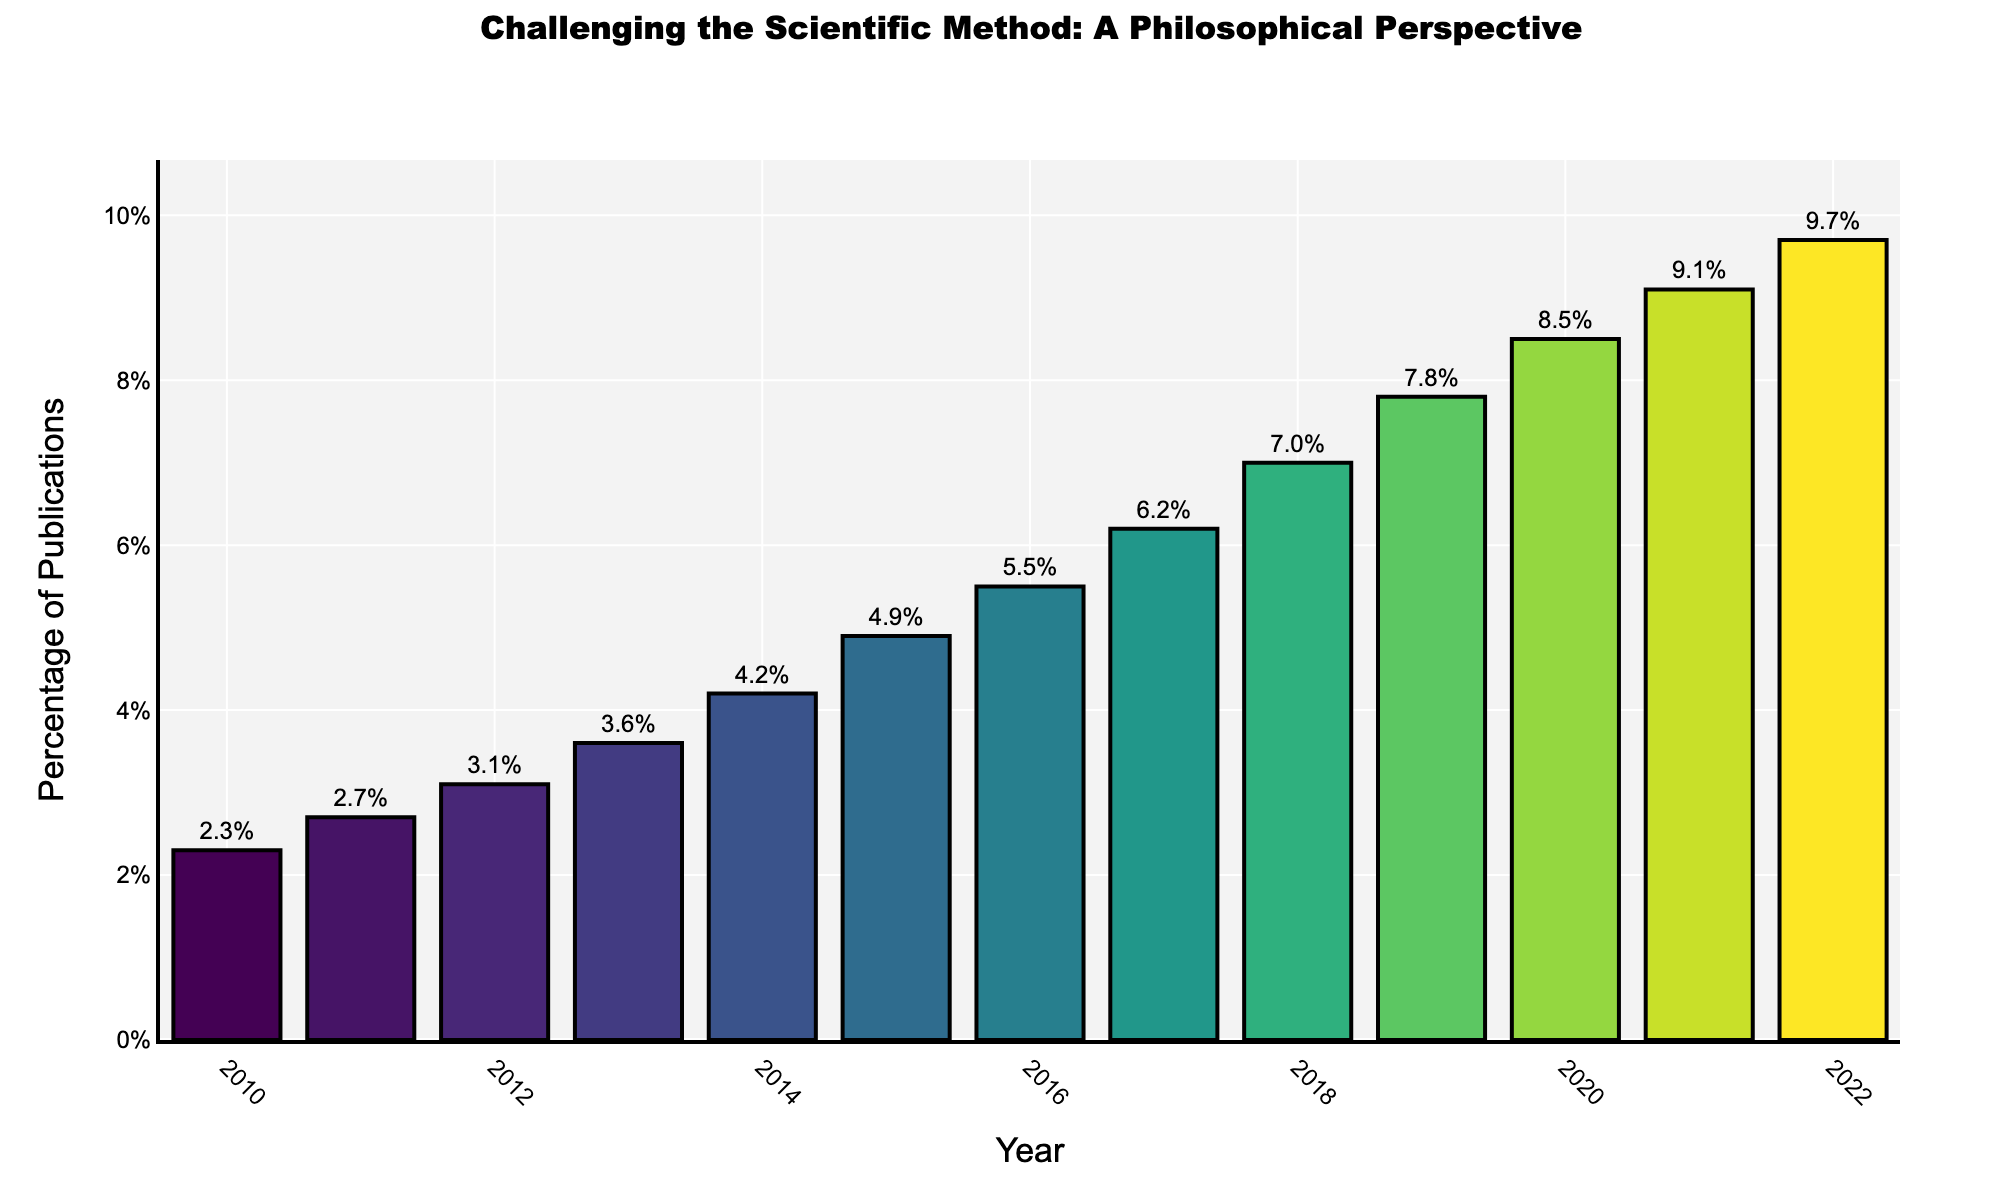What year has the highest percentage of publications challenging the scientific method? By visually observing the bar heights, the highest bar represents 2022. Hence, 2022 has the highest percentage.
Answer: 2022 How much did the percentage of publications challenging the scientific method increase from 2015 to 2020? Looking at the figure, the percentage in 2015 is 4.9% and in 2020 is 8.5%. The difference is 8.5% - 4.9% = 3.6%.
Answer: 3.6% Which year saw the largest increase in the percentage of publications compared to the previous year? Calculating the year-on-year increase: 2011 (0.4), 2012 (0.4), 2013 (0.5), 2014 (0.6), 2015 (0.7), 2016 (0.6), 2017 (0.7), 2018 (0.8), 2019 (0.8), 2020 (0.7), 2021 (0.6), 2022 (0.6). The largest increase is 0.8% between 2017-2018 and 2018-2019.
Answer: 2018 and 2019 What is the average percentage of publications from 2010 to 2022? Summing the percentages from 2010 to 2022: 2.3 + 2.7 + 3.1 + 3.6 + 4.2 + 4.9 + 5.5 + 6.2 + 7.0 + 7.8 + 8.5 + 9.1 + 9.7 = 74.6. There are 13 years, so the average is 74.6 / 13 ≈ 5.7%.
Answer: 5.7% Which year experienced the smallest percentage increase in publications challenging the scientific method compared to the previous year? Calculating year-on-year increases: 2011 (0.4), 2012 (0.4), 2013 (0.5), 2014 (0.6), 2015 (0.7), 2016 (0.6), 2017 (0.7), 2018 (0.8), 2019 (0.8), 2020 (0.7), 2021 (0.6), 2022 (0.6). The smallest increase is 0.4% occurring in 2011 and 2012.
Answer: 2011 and 2012 What is the total percentage increase in publications challenging the scientific method from 2010 to 2022? The percentage increased from 2.3% in 2010 to 9.7% in 2022. The total increase is 9.7% - 2.3% = 7.4%.
Answer: 7.4% Based on the colors of the bars, which years have the lightest colors? Colors become lighter as the percentage increases. Visually, the bars for 2021 and 2022, having the highest percentages, will be the lightest.
Answer: 2021 and 2022 